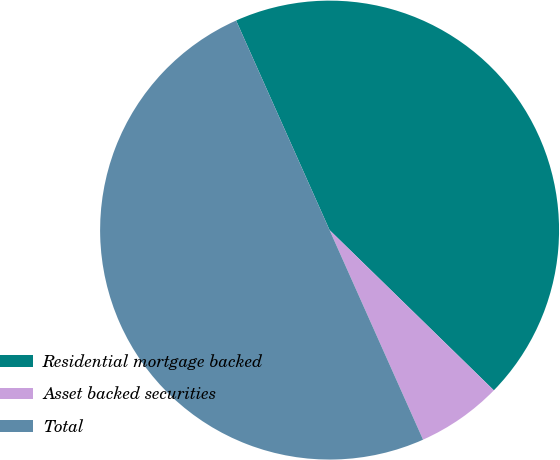<chart> <loc_0><loc_0><loc_500><loc_500><pie_chart><fcel>Residential mortgage backed<fcel>Asset backed securities<fcel>Total<nl><fcel>43.98%<fcel>6.02%<fcel>50.0%<nl></chart> 